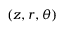Convert formula to latex. <formula><loc_0><loc_0><loc_500><loc_500>( z , r , \theta )</formula> 